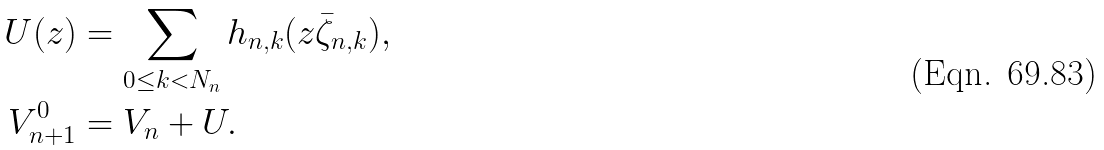<formula> <loc_0><loc_0><loc_500><loc_500>U ( z ) & = \sum _ { 0 \leq k < N _ { n } } h _ { n , k } ( z \bar { \zeta } _ { n , k } ) , \\ V ^ { 0 } _ { n + 1 } & = V _ { n } + U .</formula> 